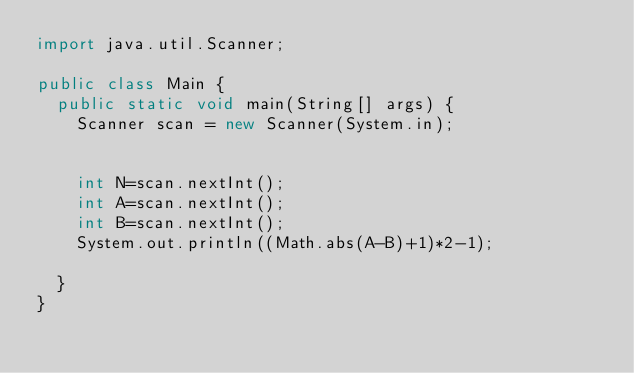<code> <loc_0><loc_0><loc_500><loc_500><_Java_>import java.util.Scanner;
 
public class Main {
	public static void main(String[] args) {
		Scanner scan = new Scanner(System.in);
 
		
		int N=scan.nextInt();
		int A=scan.nextInt();
		int B=scan.nextInt();
		System.out.println((Math.abs(A-B)+1)*2-1);
		
	}
}</code> 